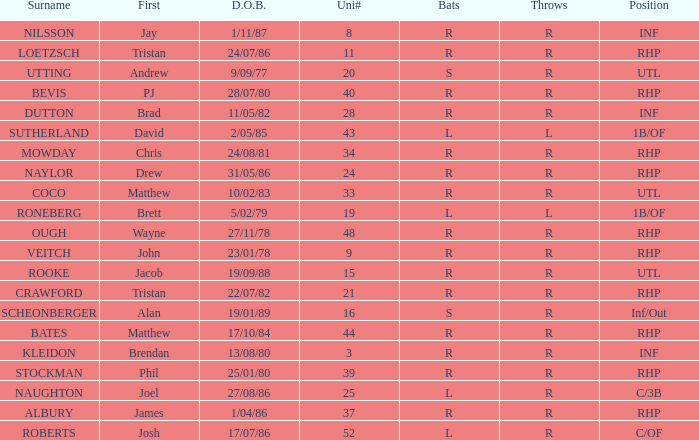Which Surname has Throws of l, and a DOB of 5/02/79? RONEBERG. 